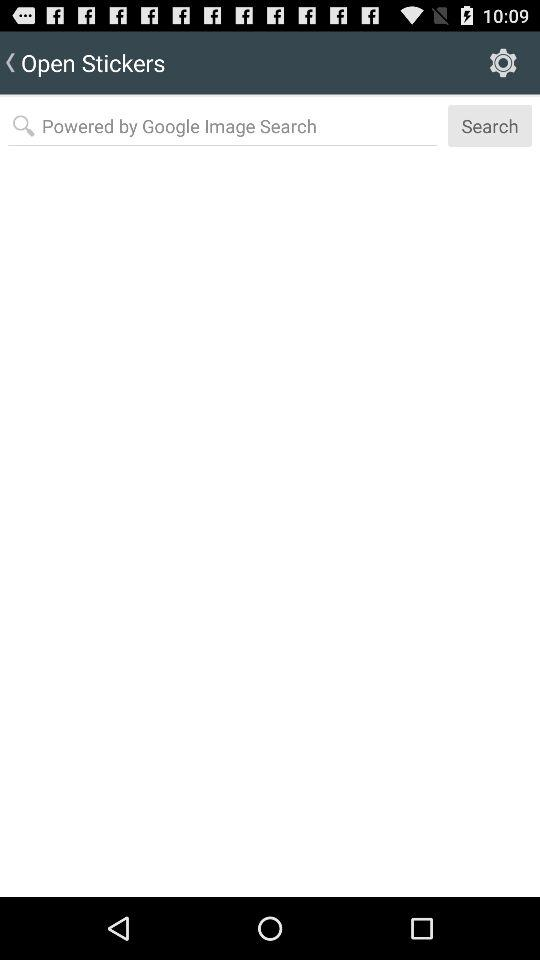How many elements are above the search bar?
Answer the question using a single word or phrase. 2 